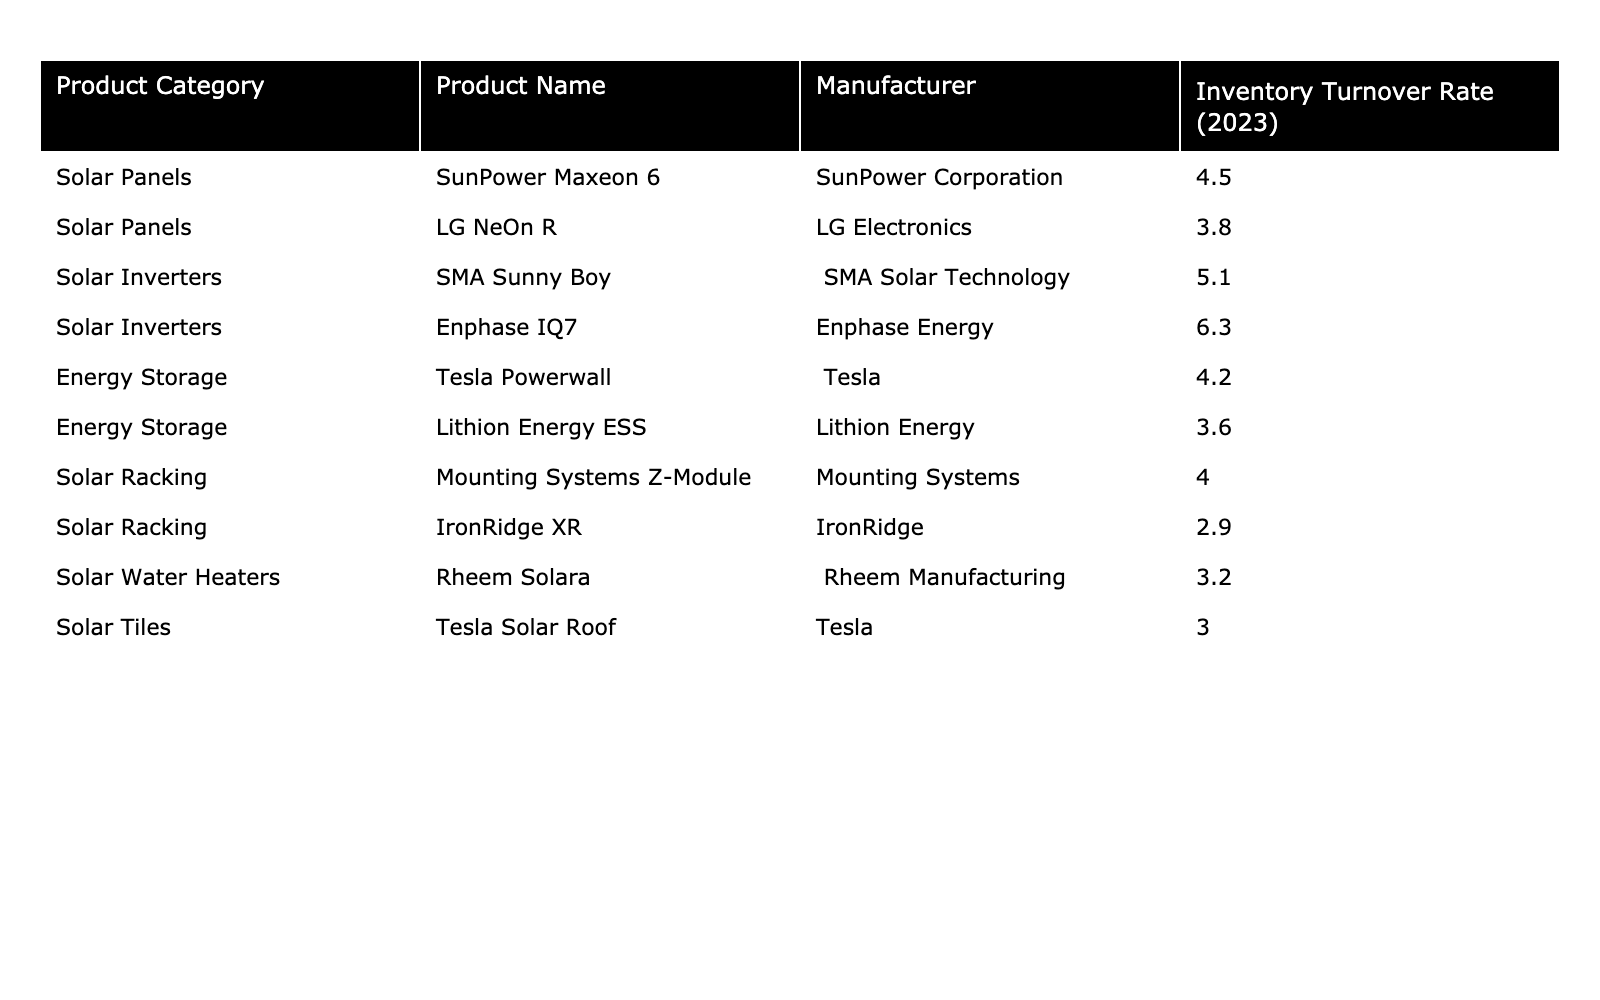What is the highest inventory turnover rate among the products listed? By reviewing the table, I can see the highest inventory turnover rate is listed for the Enphase IQ7, which shows a rate of 6.3.
Answer: 6.3 How many solar panel products are listed, and what is their average inventory turnover rate? There are two solar panel products: SunPower Maxeon 6 and LG NeOn R, with turnover rates of 4.5 and 3.8 respectively. The average is (4.5 + 3.8) / 2 = 4.15.
Answer: 4.15 Is the inventory turnover rate for Tesla Powerwall higher than that of Lithion Energy ESS? Tesla Powerwall has an inventory turnover rate of 4.2, while Lithion Energy ESS has a rate of 3.6. Since 4.2 is greater than 3.6, the statement is true.
Answer: Yes Which product category has the lowest inventory turnover rate? Examining the table, the Solar Racking category has a product, IronRidge XR, with the lowest rate of 2.9 among the listed categories.
Answer: Solar Racking What is the total inventory turnover rate of the Energy Storage category? The Energy Storage category has two products: Tesla Powerwall and Lithion Energy ESS, with turnover rates of 4.2 and 3.6. Adding these rates gives 4.2 + 3.6 = 7.8 for the total.
Answer: 7.8 Are there any products with an inventory turnover rate greater than 5? Yes, both the Enphase IQ7 (6.3) and the SMA Sunny Boy (5.1) have rates greater than 5.
Answer: Yes What is the difference in inventory turnover rates between the highest and the lowest rated products? The highest rate is from Enphase IQ7 at 6.3, and the lowest is from IronRidge XR at 2.9. The difference is 6.3 - 2.9 = 3.4.
Answer: 3.4 How many products in the Solar Racking category have an inventory turnover rate below 4? There are two products listed in the Solar Racking category, one of which (IronRidge XR with a rate of 2.9) has a turnover rate below 4, making the total count 1.
Answer: 1 Which manufacturer has the solar product with the second highest inventory turnover rate? The second highest inventory turnover rate is for the SMA Sunny Boy at 5.1, made by SMA Solar Technology, making the answer SMA Solar Technology.
Answer: SMA Solar Technology If we consider the average of all inventory turnover rates, what is it? Adding all the turnover rates gives 4.5 + 3.8 + 5.1 + 6.3 + 4.2 + 3.6 + 4.0 + 2.9 + 3.2 + 3.0 = 41.6. There are 10 products, so the average is 41.6 / 10 = 4.16.
Answer: 4.16 